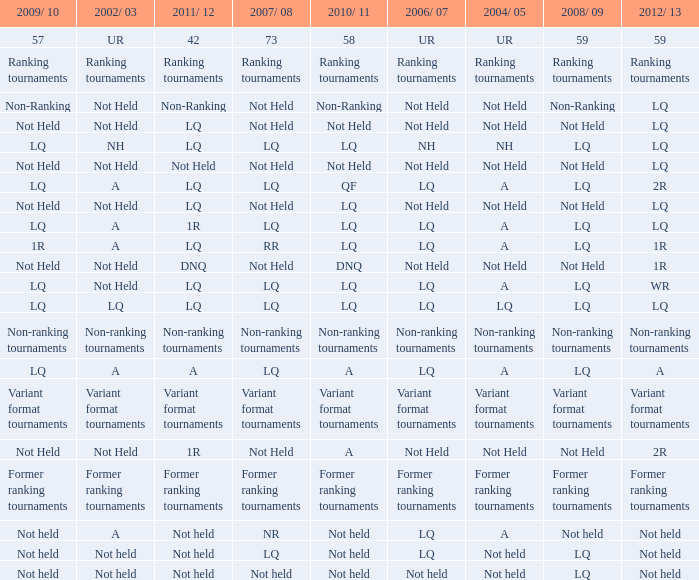I'm looking to parse the entire table for insights. Could you assist me with that? {'header': ['2009/ 10', '2002/ 03', '2011/ 12', '2007/ 08', '2010/ 11', '2006/ 07', '2004/ 05', '2008/ 09', '2012/ 13'], 'rows': [['57', 'UR', '42', '73', '58', 'UR', 'UR', '59', '59'], ['Ranking tournaments', 'Ranking tournaments', 'Ranking tournaments', 'Ranking tournaments', 'Ranking tournaments', 'Ranking tournaments', 'Ranking tournaments', 'Ranking tournaments', 'Ranking tournaments'], ['Non-Ranking', 'Not Held', 'Non-Ranking', 'Not Held', 'Non-Ranking', 'Not Held', 'Not Held', 'Non-Ranking', 'LQ'], ['Not Held', 'Not Held', 'LQ', 'Not Held', 'Not Held', 'Not Held', 'Not Held', 'Not Held', 'LQ'], ['LQ', 'NH', 'LQ', 'LQ', 'LQ', 'NH', 'NH', 'LQ', 'LQ'], ['Not Held', 'Not Held', 'Not Held', 'Not Held', 'Not Held', 'Not Held', 'Not Held', 'Not Held', 'LQ'], ['LQ', 'A', 'LQ', 'LQ', 'QF', 'LQ', 'A', 'LQ', '2R'], ['Not Held', 'Not Held', 'LQ', 'Not Held', 'LQ', 'Not Held', 'Not Held', 'Not Held', 'LQ'], ['LQ', 'A', '1R', 'LQ', 'LQ', 'LQ', 'A', 'LQ', 'LQ'], ['1R', 'A', 'LQ', 'RR', 'LQ', 'LQ', 'A', 'LQ', '1R'], ['Not Held', 'Not Held', 'DNQ', 'Not Held', 'DNQ', 'Not Held', 'Not Held', 'Not Held', '1R'], ['LQ', 'Not Held', 'LQ', 'LQ', 'LQ', 'LQ', 'A', 'LQ', 'WR'], ['LQ', 'LQ', 'LQ', 'LQ', 'LQ', 'LQ', 'LQ', 'LQ', 'LQ'], ['Non-ranking tournaments', 'Non-ranking tournaments', 'Non-ranking tournaments', 'Non-ranking tournaments', 'Non-ranking tournaments', 'Non-ranking tournaments', 'Non-ranking tournaments', 'Non-ranking tournaments', 'Non-ranking tournaments'], ['LQ', 'A', 'A', 'LQ', 'A', 'LQ', 'A', 'LQ', 'A'], ['Variant format tournaments', 'Variant format tournaments', 'Variant format tournaments', 'Variant format tournaments', 'Variant format tournaments', 'Variant format tournaments', 'Variant format tournaments', 'Variant format tournaments', 'Variant format tournaments'], ['Not Held', 'Not Held', '1R', 'Not Held', 'A', 'Not Held', 'Not Held', 'Not Held', '2R'], ['Former ranking tournaments', 'Former ranking tournaments', 'Former ranking tournaments', 'Former ranking tournaments', 'Former ranking tournaments', 'Former ranking tournaments', 'Former ranking tournaments', 'Former ranking tournaments', 'Former ranking tournaments'], ['Not held', 'A', 'Not held', 'NR', 'Not held', 'LQ', 'A', 'Not held', 'Not held'], ['Not held', 'Not held', 'Not held', 'LQ', 'Not held', 'LQ', 'Not held', 'LQ', 'Not held'], ['Not held', 'Not held', 'Not held', 'Not held', 'Not held', 'Not held', 'Not held', 'LQ', 'Not held']]} Name the 2009/10 with 2011/12 of a LQ. 